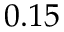Convert formula to latex. <formula><loc_0><loc_0><loc_500><loc_500>0 . 1 5</formula> 